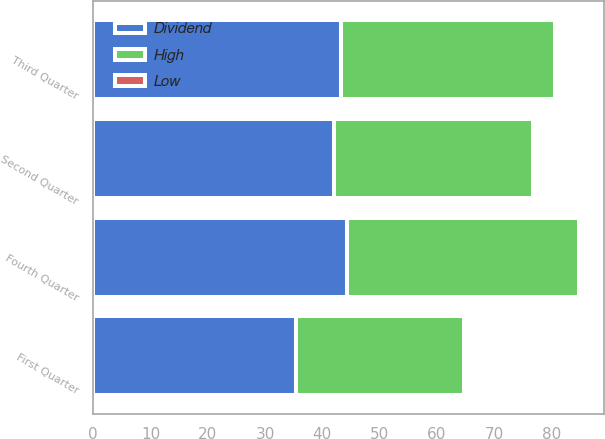Convert chart to OTSL. <chart><loc_0><loc_0><loc_500><loc_500><stacked_bar_chart><ecel><fcel>First Quarter<fcel>Second Quarter<fcel>Third Quarter<fcel>Fourth Quarter<nl><fcel>Dividend<fcel>35.38<fcel>42.09<fcel>43.17<fcel>44.22<nl><fcel>High<fcel>29.32<fcel>34.6<fcel>37.46<fcel>40.6<nl><fcel>Low<fcel>0.17<fcel>0.17<fcel>0.17<fcel>0.17<nl></chart> 